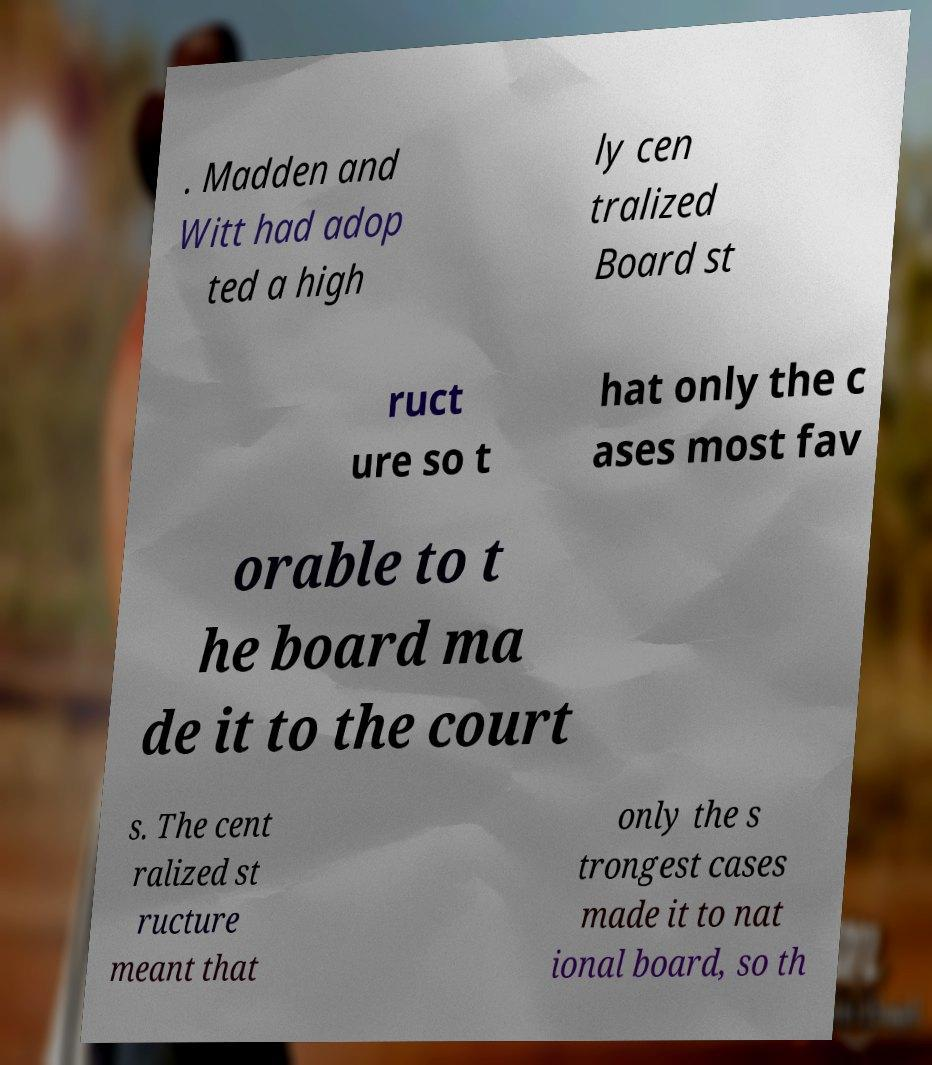Can you read and provide the text displayed in the image?This photo seems to have some interesting text. Can you extract and type it out for me? . Madden and Witt had adop ted a high ly cen tralized Board st ruct ure so t hat only the c ases most fav orable to t he board ma de it to the court s. The cent ralized st ructure meant that only the s trongest cases made it to nat ional board, so th 